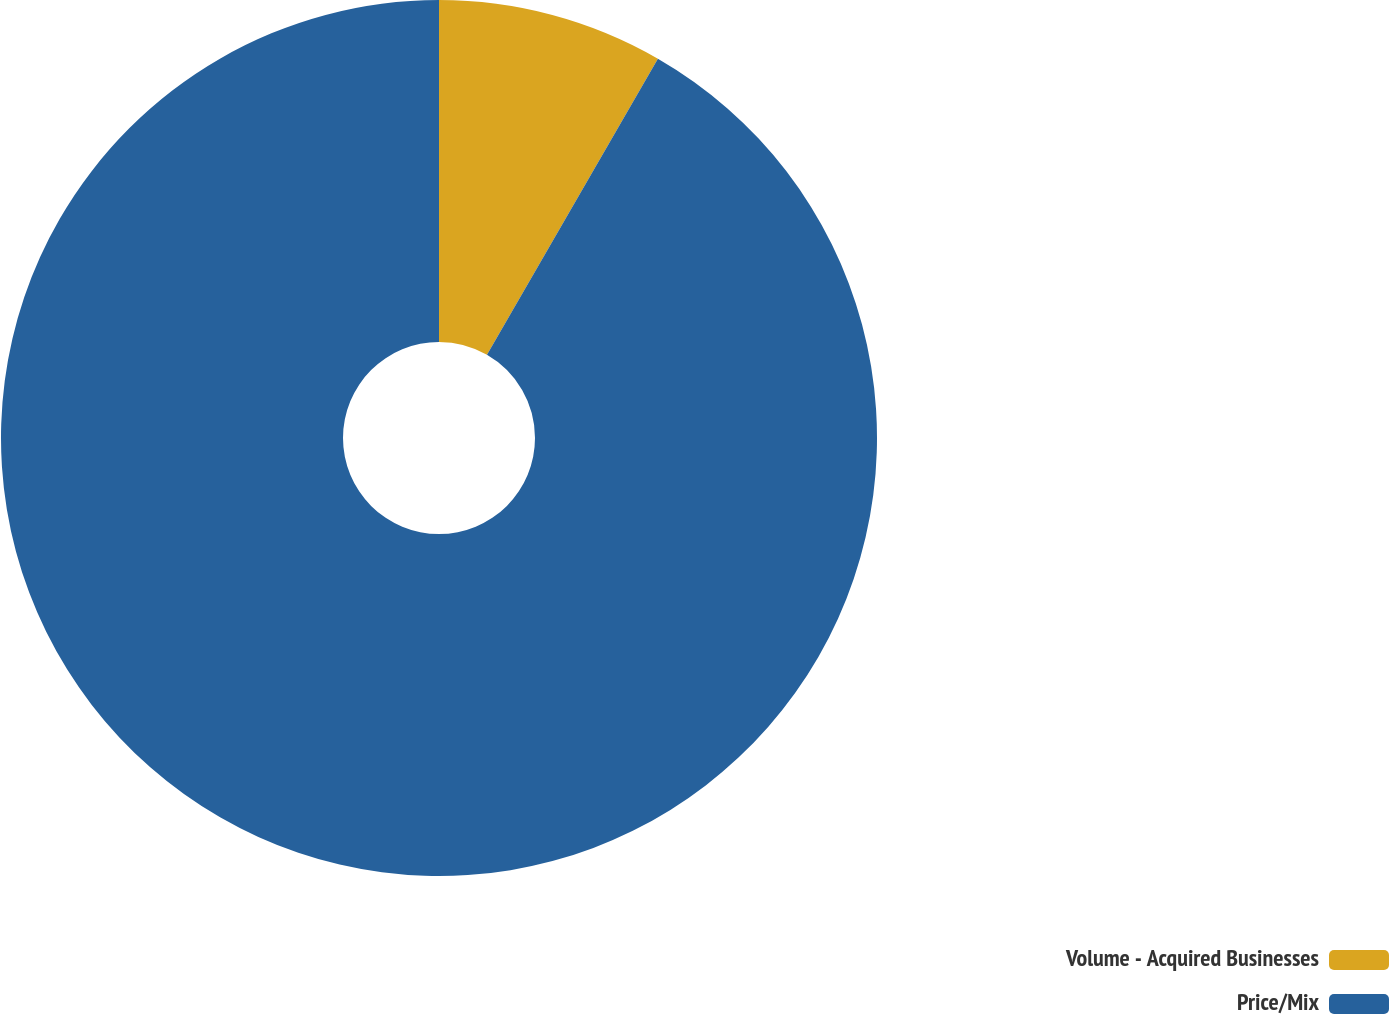Convert chart to OTSL. <chart><loc_0><loc_0><loc_500><loc_500><pie_chart><fcel>Volume - Acquired Businesses<fcel>Price/Mix<nl><fcel>8.33%<fcel>91.67%<nl></chart> 